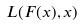Convert formula to latex. <formula><loc_0><loc_0><loc_500><loc_500>L ( F ( x ) , x )</formula> 